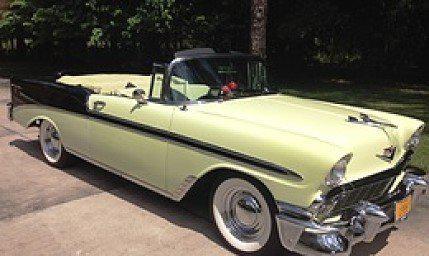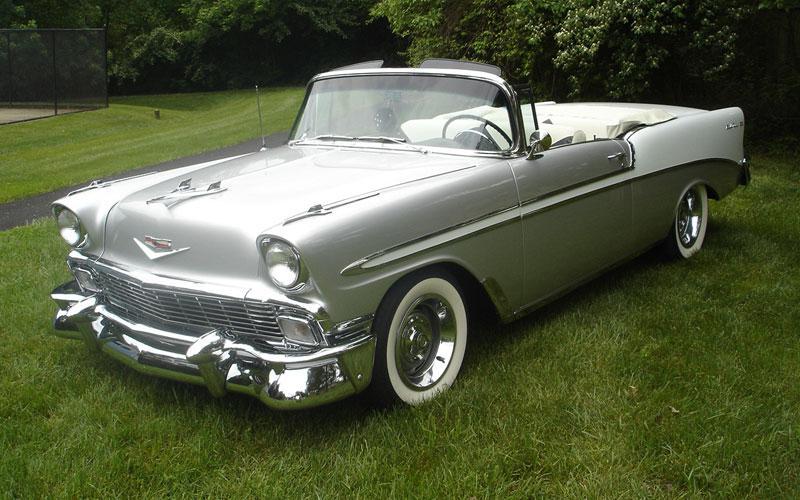The first image is the image on the left, the second image is the image on the right. For the images shown, is this caption "At least one of the cars is parked near the grass." true? Answer yes or no. Yes. 